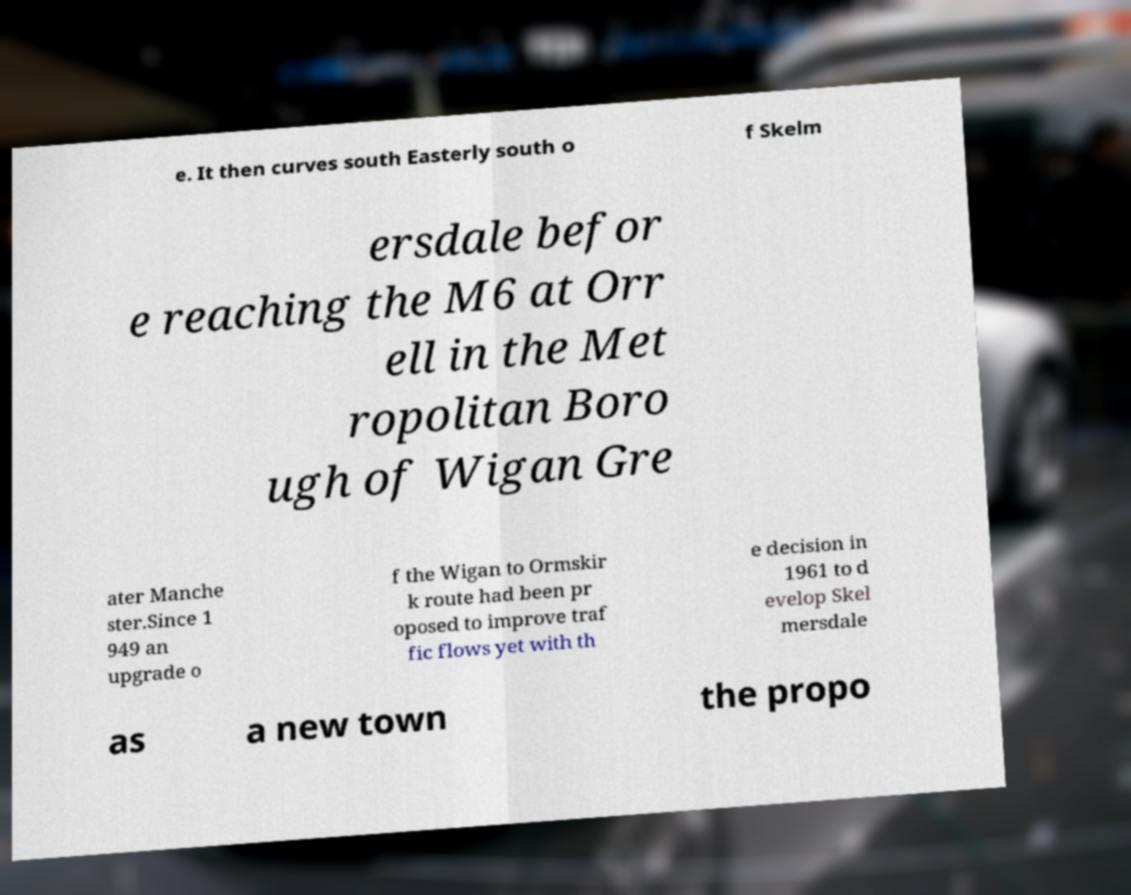Could you extract and type out the text from this image? e. It then curves south Easterly south o f Skelm ersdale befor e reaching the M6 at Orr ell in the Met ropolitan Boro ugh of Wigan Gre ater Manche ster.Since 1 949 an upgrade o f the Wigan to Ormskir k route had been pr oposed to improve traf fic flows yet with th e decision in 1961 to d evelop Skel mersdale as a new town the propo 